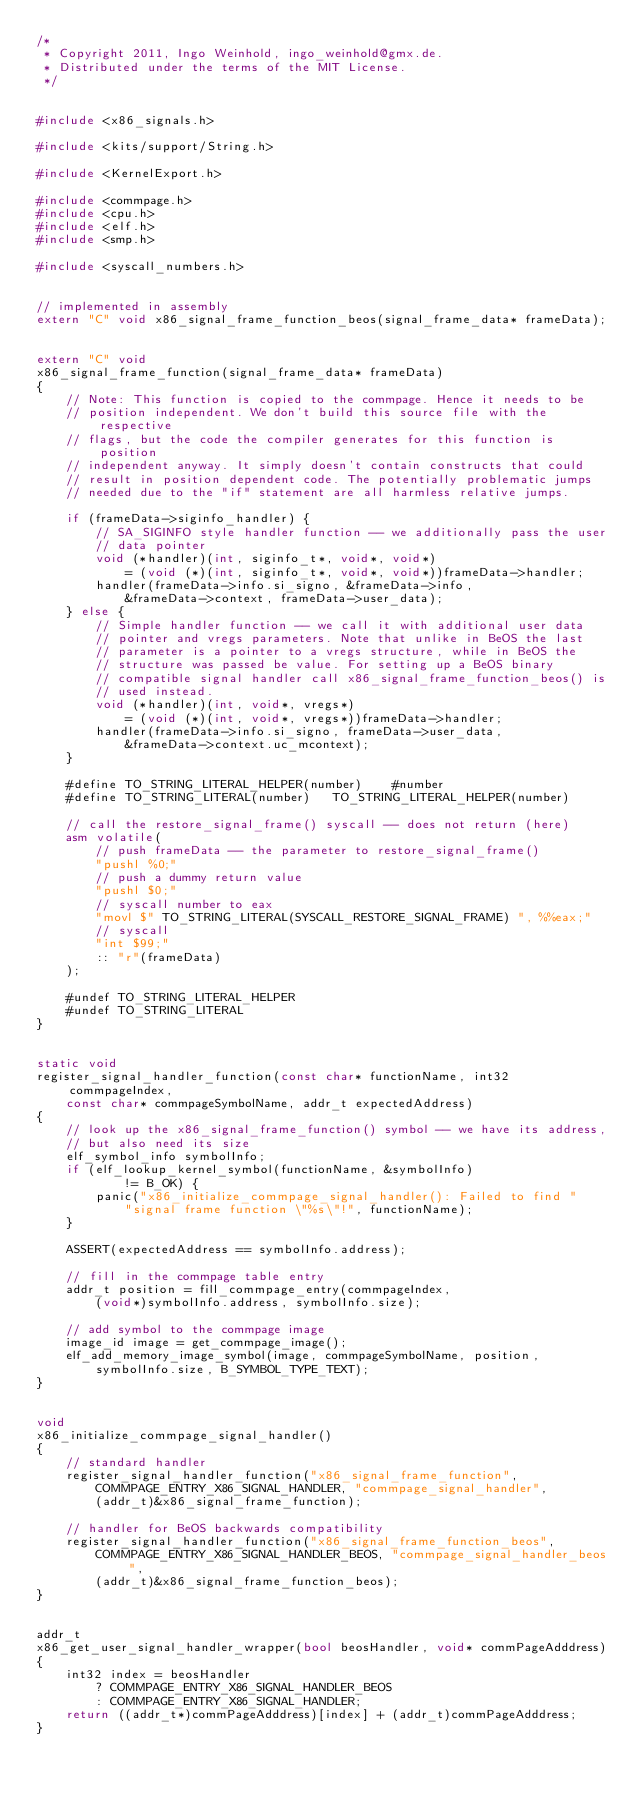<code> <loc_0><loc_0><loc_500><loc_500><_C++_>/*
 * Copyright 2011, Ingo Weinhold, ingo_weinhold@gmx.de.
 * Distributed under the terms of the MIT License.
 */


#include <x86_signals.h>

#include <kits/support/String.h>

#include <KernelExport.h>

#include <commpage.h>
#include <cpu.h>
#include <elf.h>
#include <smp.h>

#include <syscall_numbers.h>


// implemented in assembly
extern "C" void x86_signal_frame_function_beos(signal_frame_data* frameData);


extern "C" void
x86_signal_frame_function(signal_frame_data* frameData)
{
	// Note: This function is copied to the commpage. Hence it needs to be
	// position independent. We don't build this source file with the respective
	// flags, but the code the compiler generates for this function is position
	// independent anyway. It simply doesn't contain constructs that could
	// result in position dependent code. The potentially problematic jumps
	// needed due to the "if" statement are all harmless relative jumps.

	if (frameData->siginfo_handler) {
		// SA_SIGINFO style handler function -- we additionally pass the user
		// data pointer
		void (*handler)(int, siginfo_t*, void*, void*)
			= (void (*)(int, siginfo_t*, void*, void*))frameData->handler;
		handler(frameData->info.si_signo, &frameData->info,
			&frameData->context, frameData->user_data);
	} else {
		// Simple handler function -- we call it with additional user data
		// pointer and vregs parameters. Note that unlike in BeOS the last
		// parameter is a pointer to a vregs structure, while in BeOS the
		// structure was passed be value. For setting up a BeOS binary
		// compatible signal handler call x86_signal_frame_function_beos() is
		// used instead.
		void (*handler)(int, void*, vregs*)
			= (void (*)(int, void*, vregs*))frameData->handler;
		handler(frameData->info.si_signo, frameData->user_data,
			&frameData->context.uc_mcontext);
	}

	#define TO_STRING_LITERAL_HELPER(number)	#number
	#define TO_STRING_LITERAL(number)	TO_STRING_LITERAL_HELPER(number)

	// call the restore_signal_frame() syscall -- does not return (here)
	asm volatile(
		// push frameData -- the parameter to restore_signal_frame()
		"pushl %0;"
		// push a dummy return value
		"pushl $0;"
		// syscall number to eax
		"movl $" TO_STRING_LITERAL(SYSCALL_RESTORE_SIGNAL_FRAME) ", %%eax;"
		// syscall
		"int $99;"
		:: "r"(frameData)
	);

	#undef TO_STRING_LITERAL_HELPER
	#undef TO_STRING_LITERAL
}


static void
register_signal_handler_function(const char* functionName, int32 commpageIndex,
	const char* commpageSymbolName, addr_t expectedAddress)
{
	// look up the x86_signal_frame_function() symbol -- we have its address,
	// but also need its size
	elf_symbol_info symbolInfo;
	if (elf_lookup_kernel_symbol(functionName, &symbolInfo)
			!= B_OK) {
		panic("x86_initialize_commpage_signal_handler(): Failed to find "
			"signal frame function \"%s\"!", functionName);
	}

	ASSERT(expectedAddress == symbolInfo.address);

	// fill in the commpage table entry
	addr_t position = fill_commpage_entry(commpageIndex,
		(void*)symbolInfo.address, symbolInfo.size);

	// add symbol to the commpage image
	image_id image = get_commpage_image();
	elf_add_memory_image_symbol(image, commpageSymbolName, position,
		symbolInfo.size, B_SYMBOL_TYPE_TEXT);
}


void
x86_initialize_commpage_signal_handler()
{
	// standard handler
	register_signal_handler_function("x86_signal_frame_function",
		COMMPAGE_ENTRY_X86_SIGNAL_HANDLER, "commpage_signal_handler",
		(addr_t)&x86_signal_frame_function);

	// handler for BeOS backwards compatibility
	register_signal_handler_function("x86_signal_frame_function_beos",
		COMMPAGE_ENTRY_X86_SIGNAL_HANDLER_BEOS, "commpage_signal_handler_beos",
		(addr_t)&x86_signal_frame_function_beos);
}


addr_t
x86_get_user_signal_handler_wrapper(bool beosHandler, void* commPageAdddress)
{
	int32 index = beosHandler
		? COMMPAGE_ENTRY_X86_SIGNAL_HANDLER_BEOS
		: COMMPAGE_ENTRY_X86_SIGNAL_HANDLER;
	return ((addr_t*)commPageAdddress)[index] + (addr_t)commPageAdddress;
}
</code> 